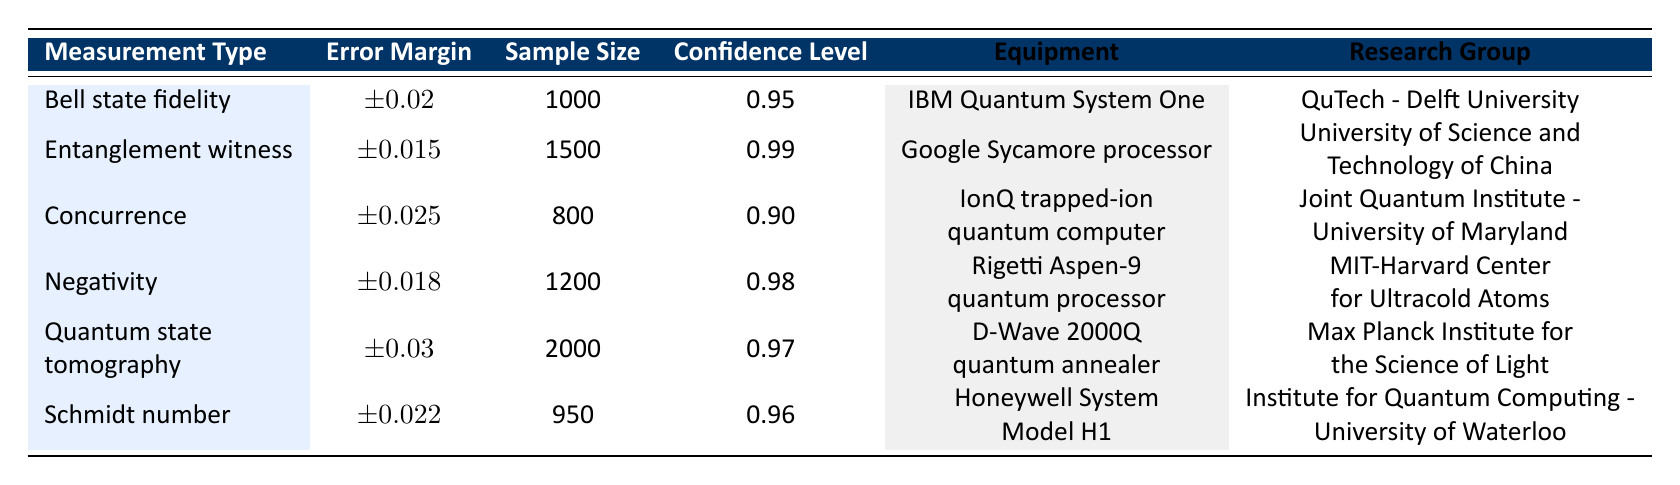What is the error margin for the Entanglement witness measurement? The error margin for the Entanglement witness measurement is listed in the second row of the table, which states it as ±0.015.
Answer: ±0.015 Which measurement type has the largest sample size? The sample sizes are listed as 1000, 1500, 800, 1200, 2000, and 950 for each measurement type. The largest sample size, 2000, corresponds to Quantum state tomography.
Answer: Quantum state tomography Is the confidence level for the Concurrence measurement greater than 0.95? The confidence level for Concurrence is stated in the table as 0.90, which is less than 0.95. Therefore, the statement is false.
Answer: No What is the average error margin across all measurement types? The error margins listed are ±0.02, ±0.015, ±0.025, ±0.018, ±0.03, and ±0.022. Calculating the average gives (0.02 + 0.015 + 0.025 + 0.018 + 0.03 + 0.022) / 6 = 0.020
Answer: ±0.020 Which research group has conducted a measurement with an error margin less than ±0.02? By examining the error margins of each measurement type, the Entanglement witness (±0.015) has an error margin less than ±0.02, and it is associated with the University of Science and Technology of China.
Answer: University of Science and Technology of China Is there a measurement with a confidence level of 0.97? The confidence levels stated in the table are 0.95, 0.99, 0.90, 0.98, 0.97, and 0.96. Since the confidence level of 0.97 appears in the row for Quantum state tomography, the answer is yes.
Answer: Yes What is the difference in confidence level between the Entanglement witness and the Schmidt number measurements? The confidence level for Entanglement witness is 0.99, and for Schmidt number, it is 0.96. The difference is 0.99 - 0.96 = 0.03.
Answer: 0.03 Which measurement type is associated with the lowest error margin? The error margins for each measurement type are compared: ±0.02, ±0.015, ±0.025, ±0.018, ±0.03, and ±0.022, and the lowest is ±0.015 for the Entanglement witness.
Answer: Entanglement witness 